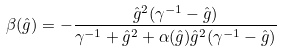<formula> <loc_0><loc_0><loc_500><loc_500>\beta ( \hat { g } ) = - \frac { \hat { g } ^ { 2 } ( \gamma ^ { - 1 } - \hat { g } ) } { \gamma ^ { - 1 } + \hat { g } ^ { 2 } + \alpha ( \hat { g } ) \hat { g } ^ { 2 } ( \gamma ^ { - 1 } - \hat { g } ) }</formula> 